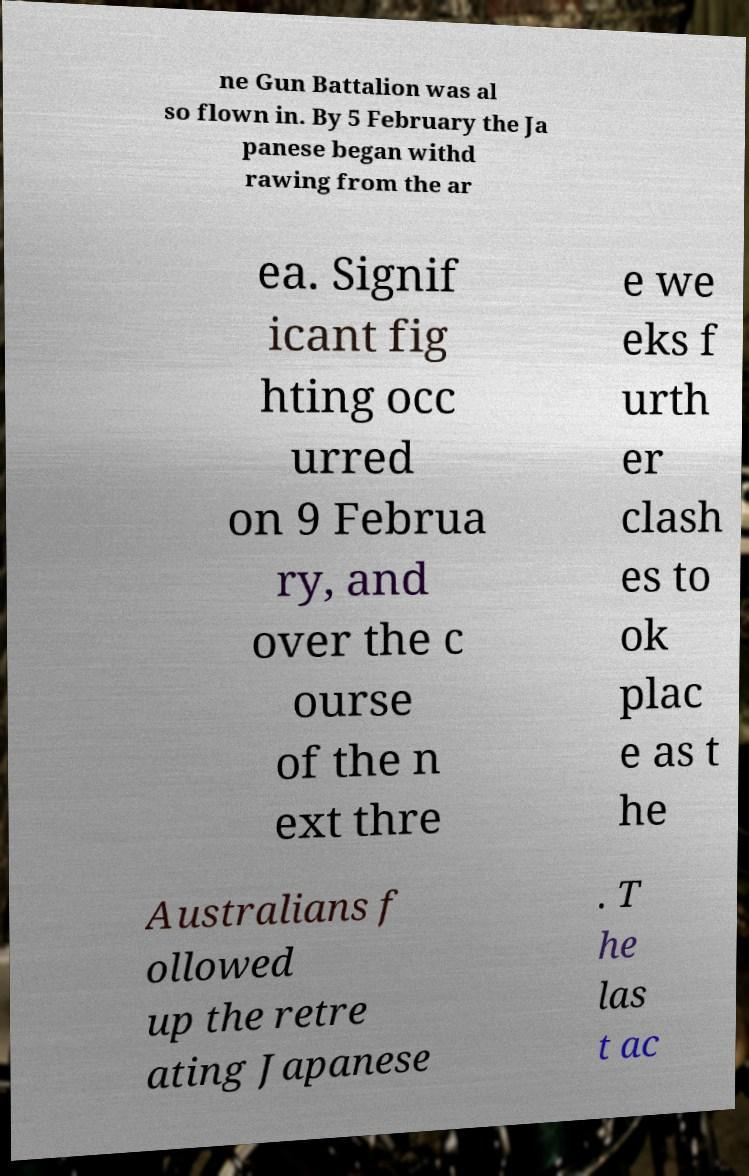Please read and relay the text visible in this image. What does it say? ne Gun Battalion was al so flown in. By 5 February the Ja panese began withd rawing from the ar ea. Signif icant fig hting occ urred on 9 Februa ry, and over the c ourse of the n ext thre e we eks f urth er clash es to ok plac e as t he Australians f ollowed up the retre ating Japanese . T he las t ac 